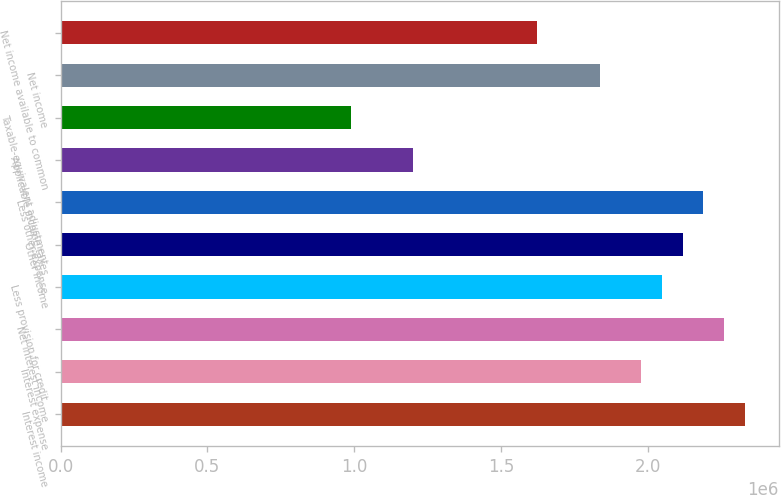Convert chart to OTSL. <chart><loc_0><loc_0><loc_500><loc_500><bar_chart><fcel>Interest income<fcel>Interest expense<fcel>Net interest income<fcel>Less provision for credit<fcel>Other income<fcel>Less other expense<fcel>Applicable income taxes<fcel>Taxable-equivalent adjustment<fcel>Net income<fcel>Net income available to common<nl><fcel>2.33108e+06<fcel>1.97789e+06<fcel>2.26044e+06<fcel>2.04852e+06<fcel>2.11916e+06<fcel>2.1898e+06<fcel>1.20086e+06<fcel>988943<fcel>1.83661e+06<fcel>1.62469e+06<nl></chart> 